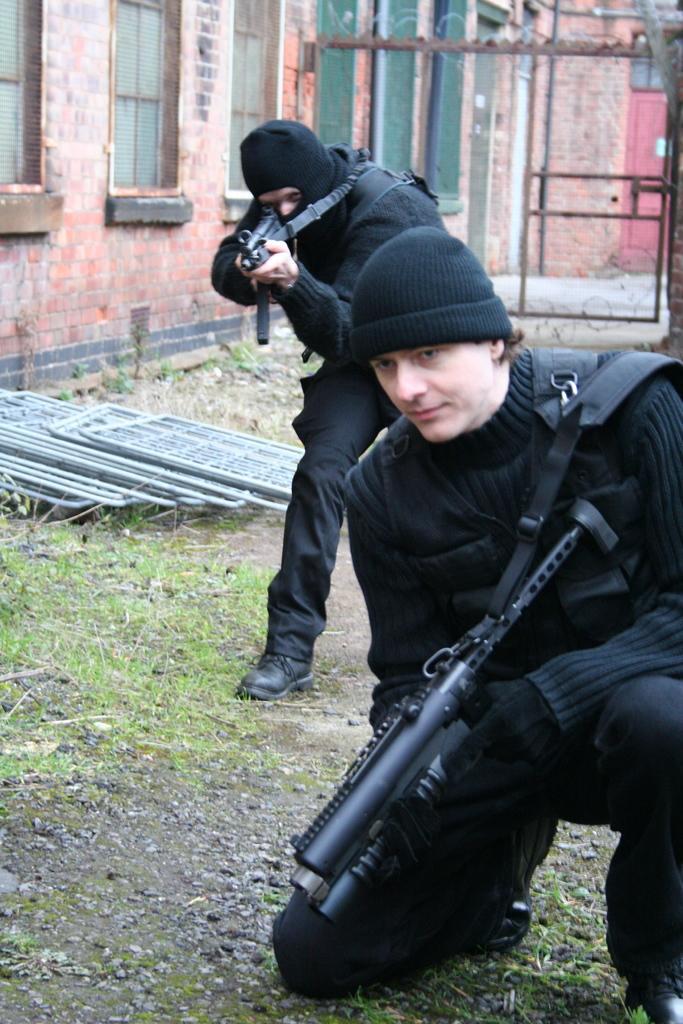In one or two sentences, can you explain what this image depicts? In the foreground of the picture we can see people holding guns and there are some iron frames, grass, soil and stones. In the background we can see buildings, windows, fencing, door and other objects. 